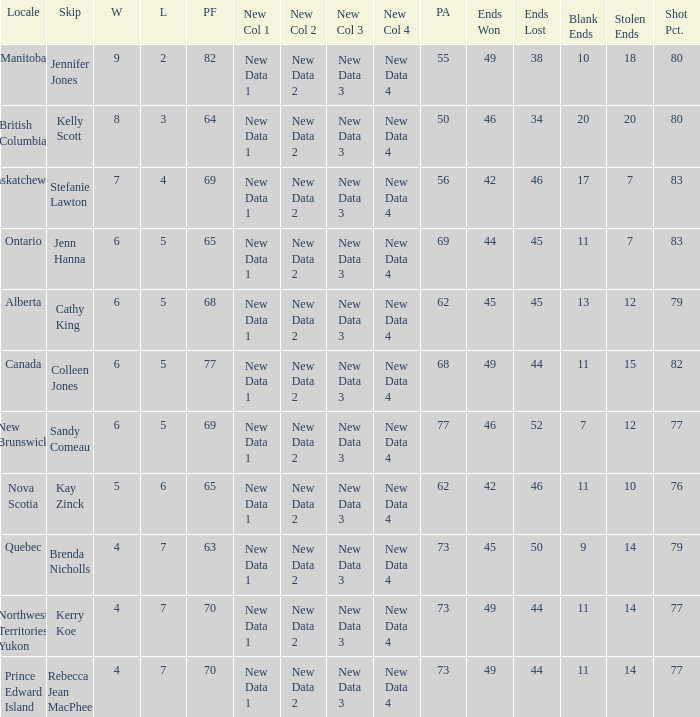What is the minimum PA when ends lost is 45? 62.0. 